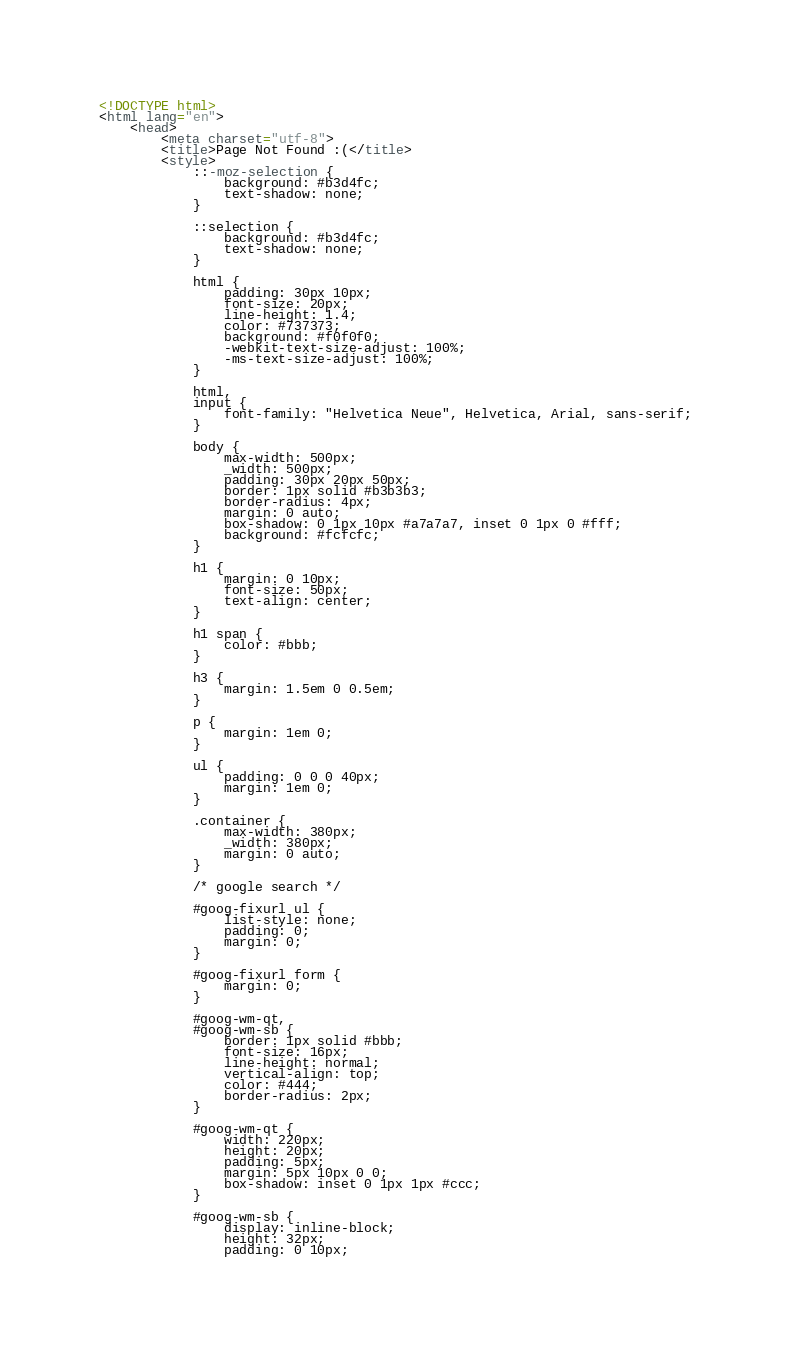Convert code to text. <code><loc_0><loc_0><loc_500><loc_500><_HTML_><!DOCTYPE html>
<html lang="en">
	<head>
		<meta charset="utf-8">
		<title>Page Not Found :(</title>
		<style>
			::-moz-selection {
				background: #b3d4fc;
				text-shadow: none;
			}

			::selection {
				background: #b3d4fc;
				text-shadow: none;
			}

			html {
				padding: 30px 10px;
				font-size: 20px;
				line-height: 1.4;
				color: #737373;
				background: #f0f0f0;
				-webkit-text-size-adjust: 100%;
				-ms-text-size-adjust: 100%;
			}

			html,
			input {
				font-family: "Helvetica Neue", Helvetica, Arial, sans-serif;
			}

			body {
				max-width: 500px;
				_width: 500px;
				padding: 30px 20px 50px;
				border: 1px solid #b3b3b3;
				border-radius: 4px;
				margin: 0 auto;
				box-shadow: 0 1px 10px #a7a7a7, inset 0 1px 0 #fff;
				background: #fcfcfc;
			}

			h1 {
				margin: 0 10px;
				font-size: 50px;
				text-align: center;
			}

			h1 span {
				color: #bbb;
			}

			h3 {
				margin: 1.5em 0 0.5em;
			}

			p {
				margin: 1em 0;
			}

			ul {
				padding: 0 0 0 40px;
				margin: 1em 0;
			}

			.container {
				max-width: 380px;
				_width: 380px;
				margin: 0 auto;
			}

			/* google search */

			#goog-fixurl ul {
				list-style: none;
				padding: 0;
				margin: 0;
			}

			#goog-fixurl form {
				margin: 0;
			}

			#goog-wm-qt,
			#goog-wm-sb {
				border: 1px solid #bbb;
				font-size: 16px;
				line-height: normal;
				vertical-align: top;
				color: #444;
				border-radius: 2px;
			}

			#goog-wm-qt {
				width: 220px;
				height: 20px;
				padding: 5px;
				margin: 5px 10px 0 0;
				box-shadow: inset 0 1px 1px #ccc;
			}

			#goog-wm-sb {
				display: inline-block;
				height: 32px;
				padding: 0 10px;</code> 